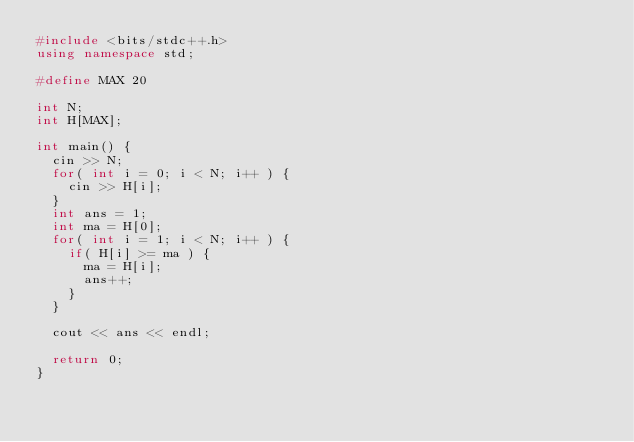Convert code to text. <code><loc_0><loc_0><loc_500><loc_500><_C++_>#include <bits/stdc++.h>
using namespace std;

#define MAX 20

int N;
int H[MAX];

int main() {
	cin >> N;
	for( int i = 0; i < N; i++ ) {
		cin >> H[i];
	}
	int ans = 1;
	int ma = H[0];
	for( int i = 1; i < N; i++ ) {
		if( H[i] >= ma ) {
			ma = H[i];
			ans++;
		}
	}

	cout << ans << endl;

	return 0;
}
</code> 